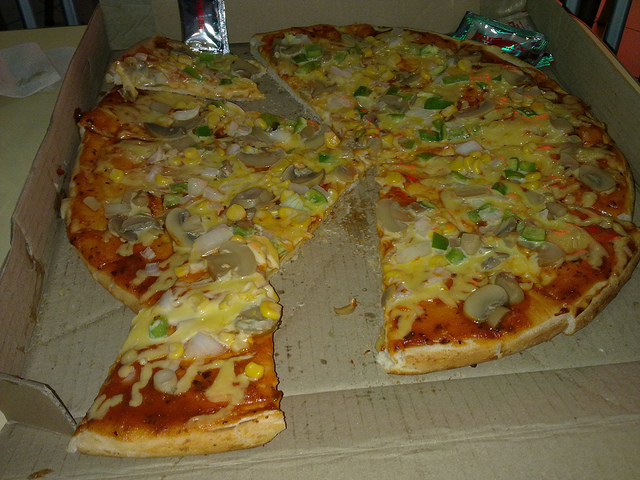<image>What is the name for this pizza recipe? I am not sure about the name of this pizza recipe. It can be 'mushroom', 'veggie', 'vegetarian' or 'cheese'. What is the name for this pizza recipe? I am not sure of the name for this pizza recipe. It can be mushroom, veggie, vegetarian, or cheese. 